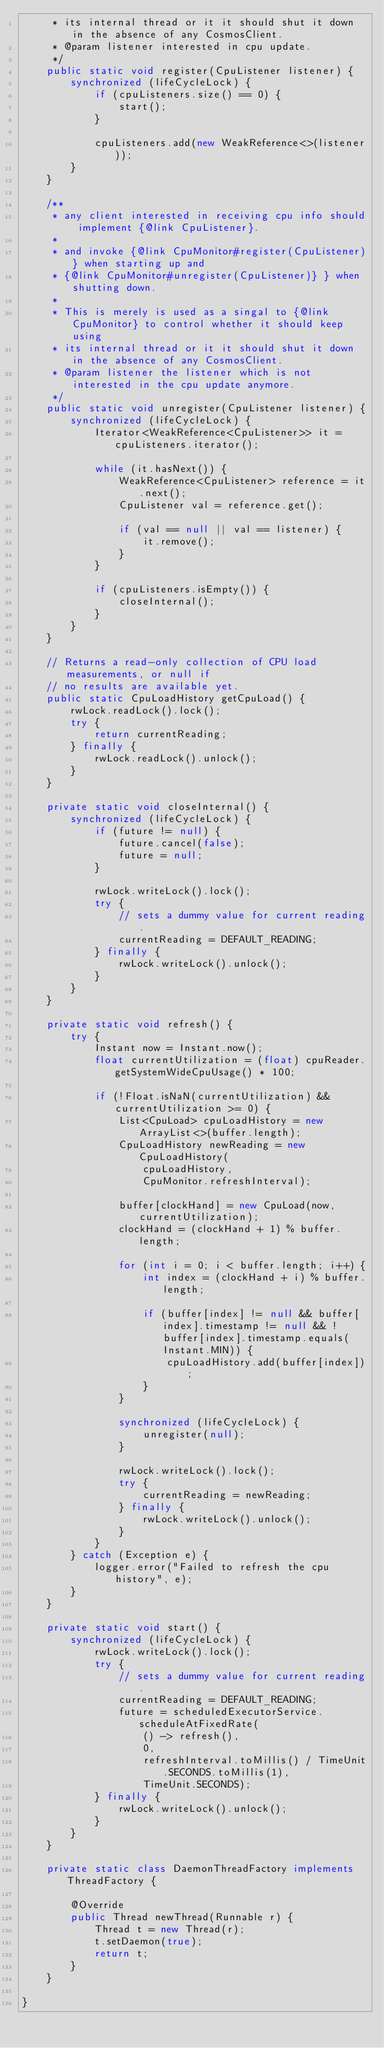Convert code to text. <code><loc_0><loc_0><loc_500><loc_500><_Java_>     * its internal thread or it it should shut it down in the absence of any CosmosClient.
     * @param listener interested in cpu update.
     */
    public static void register(CpuListener listener) {
        synchronized (lifeCycleLock) {
            if (cpuListeners.size() == 0) {
                start();
            }

            cpuListeners.add(new WeakReference<>(listener));
        }
    }

    /**
     * any client interested in receiving cpu info should implement {@link CpuListener}.
     *
     * and invoke {@link CpuMonitor#register(CpuListener)} when starting up and
     * {@link CpuMonitor#unregister(CpuListener)} } when shutting down.
     *
     * This is merely is used as a singal to {@link CpuMonitor} to control whether it should keep using
     * its internal thread or it it should shut it down in the absence of any CosmosClient.
     * @param listener the listener which is not interested in the cpu update anymore.
     */
    public static void unregister(CpuListener listener) {
        synchronized (lifeCycleLock) {
            Iterator<WeakReference<CpuListener>> it = cpuListeners.iterator();

            while (it.hasNext()) {
                WeakReference<CpuListener> reference = it.next();
                CpuListener val = reference.get();

                if (val == null || val == listener) {
                    it.remove();
                }
            }

            if (cpuListeners.isEmpty()) {
                closeInternal();
            }
        }
    }

    // Returns a read-only collection of CPU load measurements, or null if
    // no results are available yet.
    public static CpuLoadHistory getCpuLoad() {
        rwLock.readLock().lock();
        try {
            return currentReading;
        } finally {
            rwLock.readLock().unlock();
        }
    }

    private static void closeInternal() {
        synchronized (lifeCycleLock) {
            if (future != null) {
                future.cancel(false);
                future = null;
            }

            rwLock.writeLock().lock();
            try {
                // sets a dummy value for current reading.
                currentReading = DEFAULT_READING;
            } finally {
                rwLock.writeLock().unlock();
            }
        }
    }

    private static void refresh() {
        try {
            Instant now = Instant.now();
            float currentUtilization = (float) cpuReader.getSystemWideCpuUsage() * 100;

            if (!Float.isNaN(currentUtilization) && currentUtilization >= 0) {
                List<CpuLoad> cpuLoadHistory = new ArrayList<>(buffer.length);
                CpuLoadHistory newReading = new CpuLoadHistory(
                    cpuLoadHistory,
                    CpuMonitor.refreshInterval);

                buffer[clockHand] = new CpuLoad(now, currentUtilization);
                clockHand = (clockHand + 1) % buffer.length;

                for (int i = 0; i < buffer.length; i++) {
                    int index = (clockHand + i) % buffer.length;

                    if (buffer[index] != null && buffer[index].timestamp != null && !buffer[index].timestamp.equals(Instant.MIN)) {
                        cpuLoadHistory.add(buffer[index]);
                    }
                }

                synchronized (lifeCycleLock) {
                    unregister(null);
                }

                rwLock.writeLock().lock();
                try {
                    currentReading = newReading;
                } finally {
                    rwLock.writeLock().unlock();
                }
            }
        } catch (Exception e) {
            logger.error("Failed to refresh the cpu history", e);
        }
    }

    private static void start() {
        synchronized (lifeCycleLock) {
            rwLock.writeLock().lock();
            try {
                // sets a dummy value for current reading.
                currentReading = DEFAULT_READING;
                future = scheduledExecutorService.scheduleAtFixedRate(
                    () -> refresh(),
                    0,
                    refreshInterval.toMillis() / TimeUnit.SECONDS.toMillis(1),
                    TimeUnit.SECONDS);
            } finally {
                rwLock.writeLock().unlock();
            }
        }
    }

    private static class DaemonThreadFactory implements ThreadFactory {

        @Override
        public Thread newThread(Runnable r) {
            Thread t = new Thread(r);
            t.setDaemon(true);
            return t;
        }
    }

}
</code> 